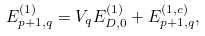<formula> <loc_0><loc_0><loc_500><loc_500>E _ { p + 1 , q } ^ { ( 1 ) } = V _ { q } E _ { D , 0 } ^ { ( 1 ) } + E _ { p + 1 , q } ^ { ( 1 , c ) } ,</formula> 